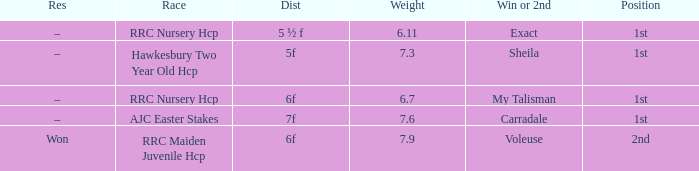What was the name of the winner or 2nd when the result was –, and weight was 6.7? My Talisman. 